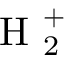Convert formula to latex. <formula><loc_0><loc_0><loc_500><loc_500>H _ { 2 } ^ { + }</formula> 